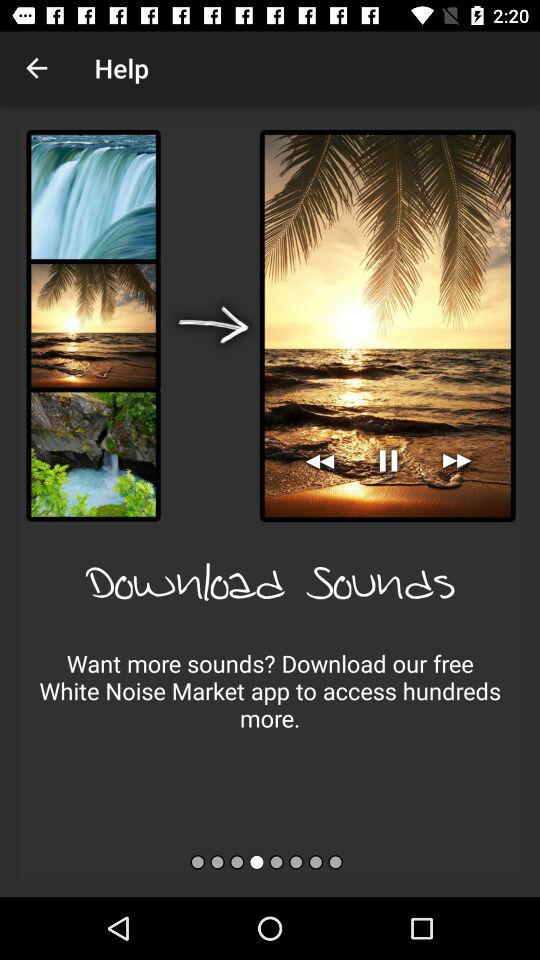What is the application name? The application name is "White Noise Market". 